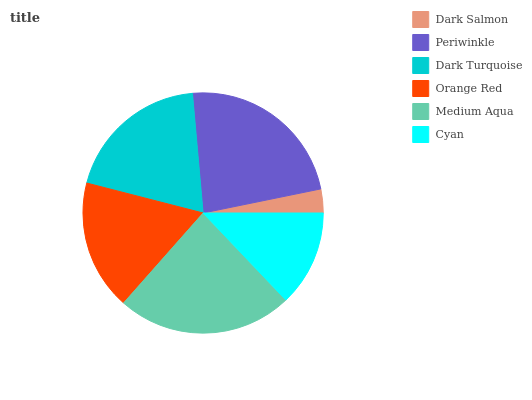Is Dark Salmon the minimum?
Answer yes or no. Yes. Is Medium Aqua the maximum?
Answer yes or no. Yes. Is Periwinkle the minimum?
Answer yes or no. No. Is Periwinkle the maximum?
Answer yes or no. No. Is Periwinkle greater than Dark Salmon?
Answer yes or no. Yes. Is Dark Salmon less than Periwinkle?
Answer yes or no. Yes. Is Dark Salmon greater than Periwinkle?
Answer yes or no. No. Is Periwinkle less than Dark Salmon?
Answer yes or no. No. Is Dark Turquoise the high median?
Answer yes or no. Yes. Is Orange Red the low median?
Answer yes or no. Yes. Is Cyan the high median?
Answer yes or no. No. Is Dark Salmon the low median?
Answer yes or no. No. 